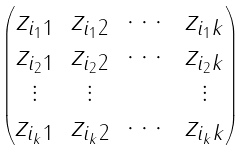<formula> <loc_0><loc_0><loc_500><loc_500>\begin{pmatrix} z _ { i _ { 1 } 1 } & z _ { i _ { 1 } 2 } & \cdots & z _ { i _ { 1 } k } \\ z _ { i _ { 2 } 1 } & z _ { i _ { 2 } 2 } & \cdots & z _ { i _ { 2 } k } \\ \vdots & \vdots & & \vdots \\ z _ { i _ { k } 1 } & z _ { i _ { k } 2 } & \cdots & z _ { i _ { k } k } \end{pmatrix}</formula> 